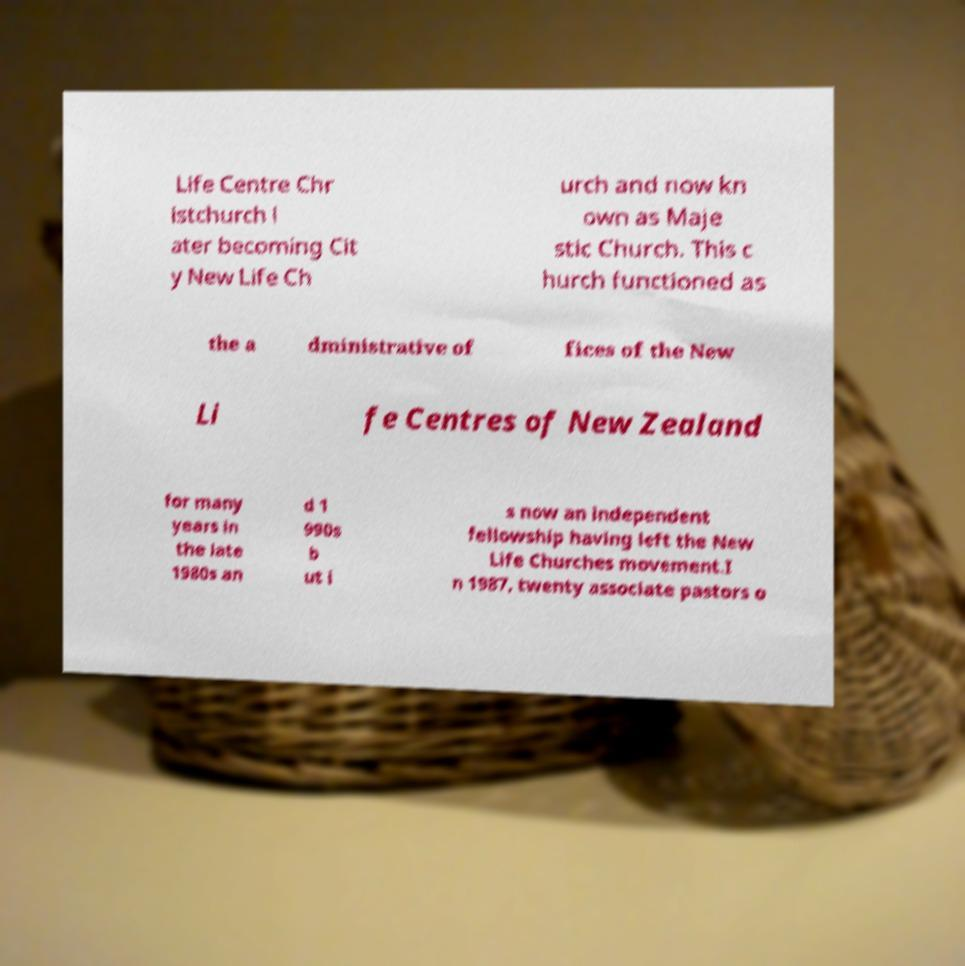Could you assist in decoding the text presented in this image and type it out clearly? Life Centre Chr istchurch l ater becoming Cit y New Life Ch urch and now kn own as Maje stic Church. This c hurch functioned as the a dministrative of fices of the New Li fe Centres of New Zealand for many years in the late 1980s an d 1 990s b ut i s now an independent fellowship having left the New Life Churches movement.I n 1987, twenty associate pastors o 